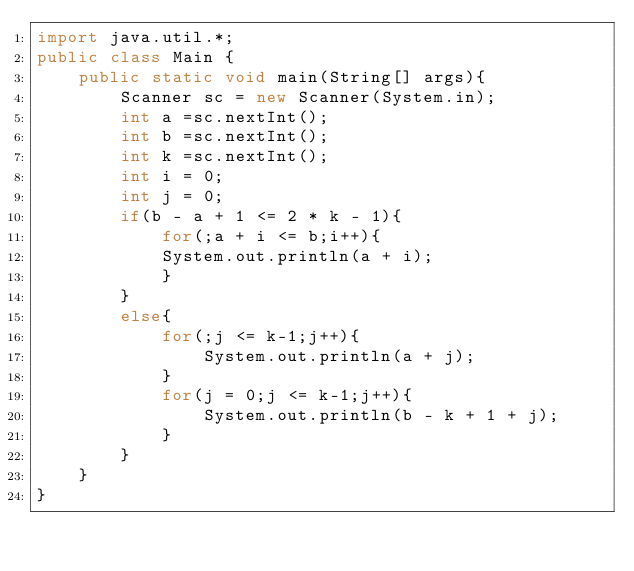<code> <loc_0><loc_0><loc_500><loc_500><_Java_>import java.util.*;
public class Main {
		public static void main(String[] args){
    		Scanner sc = new Scanner(System.in);
        int a =sc.nextInt();
        int b =sc.nextInt();
        int k =sc.nextInt();
				int i = 0;
				int j = 0;
				if(b - a + 1 <= 2 * k - 1){
						for(;a + i <= b;i++){
						System.out.println(a + i);
						}
				}
				else{
						for(;j <= k-1;j++){
								System.out.println(a + j);
						}
						for(j = 0;j <= k-1;j++){
								System.out.println(b - k + 1 + j);
						}
				}
    }
}
</code> 